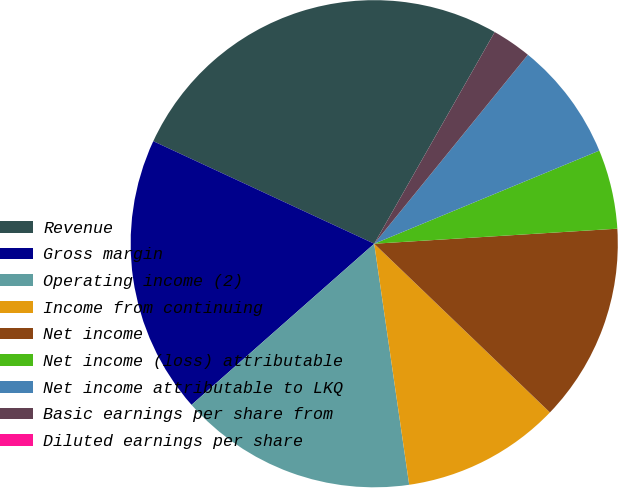Convert chart. <chart><loc_0><loc_0><loc_500><loc_500><pie_chart><fcel>Revenue<fcel>Gross margin<fcel>Operating income (2)<fcel>Income from continuing<fcel>Net income<fcel>Net income (loss) attributable<fcel>Net income attributable to LKQ<fcel>Basic earnings per share from<fcel>Diluted earnings per share<nl><fcel>26.32%<fcel>18.42%<fcel>15.79%<fcel>10.53%<fcel>13.16%<fcel>5.26%<fcel>7.89%<fcel>2.63%<fcel>0.0%<nl></chart> 